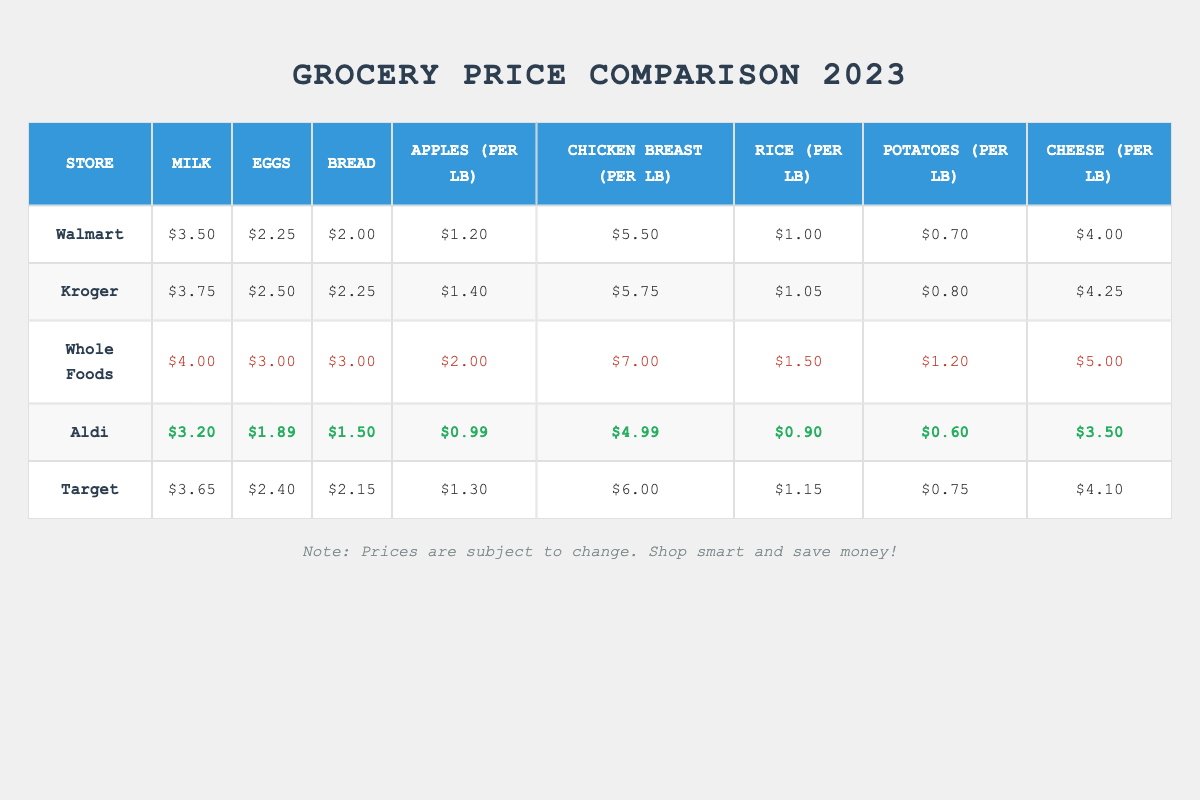What is the price of milk at Aldi? The table lists the price of milk at Aldi as $3.20, which can be found in the row corresponding to Aldi under the milk column.
Answer: $3.20 Which store offers the cheapest eggs? By comparing the prices of eggs across the stores, Aldi has the lowest price at $1.89, which can be seen in the eggs column corresponding to Aldi.
Answer: Aldi How much more expensive is chicken breast per pound at Whole Foods than at Aldi? The price of chicken breast at Whole Foods is $7.00 and at Aldi it is $4.99. The difference is $7.00 - $4.99 = $2.01, showing Whole Foods charges $2.01 more per pound.
Answer: $2.01 What is the highest price for cheese per pound and which store sells it? The highest price for cheese per pound is $5.00, found at Whole Foods in the cheese column, making it the most expensive option.
Answer: $5.00 at Whole Foods Are the prices of apples at Walmart and Kroger the same? Walmart offers apples at $1.20 per pound, while Kroger charges $1.40 per pound. Since these two values are different, they are not the same.
Answer: No What is the average price of bread across all stores? The prices for bread from each store are $2.00 (Walmart), $2.25 (Kroger), $3.00 (Whole Foods), $1.50 (Aldi), and $2.15 (Target). The total sum is $2.00 + $2.25 + $3.00 + $1.50 + $2.15 = $10.90. There are 5 stores, so the average is $10.90 / 5 = $2.18.
Answer: $2.18 Which store has the lowest total grocery price for all items combined? The total prices for each store are calculated by adding the costs of all items: Walmart ($3.50 + $2.25 + $2.00 + $1.20 + $5.50 + $1.00 + $0.70 + $4.00 = $19.15), Kroger ($3.75 + $2.50 + $2.25 + $1.40 + $5.75 + $1.05 + $0.80 + $4.25 = $21.75), Whole Foods ($4.00 + $3.00 + $3.00 + $2.00 + $7.00 + $1.50 + $1.20 + $5.00 = $26.70), Aldi ($3.20 + $1.89 + $1.50 + $0.99 + $4.99 + $0.90 + $0.60 + $3.50 = $17.57), and Target ($3.65 + $2.40 + $2.15 + $1.30 + $6.00 + $1.15 + $0.75 + $4.10 = $21.45). The lowest total is from Aldi at $17.57.
Answer: Aldi What is the difference in price for potatoes per pound between Walmart and Whole Foods? Walmart prices potatoes at $0.70 per pound while Whole Foods prices them at $1.20 per pound. The difference is $1.20 - $0.70 = $0.50.
Answer: $0.50 Is the price of rice at Kroger higher than at Aldi? At Kroger, rice costs $1.05 per pound, while Aldi offers it for $0.90. Since $1.05 is greater than $0.90, the price at Kroger is higher.
Answer: Yes Which store has the most expensive chicken breast? The price of chicken breast at each store is: Walmart ($5.50), Kroger ($5.75), Whole Foods ($7.00), Aldi ($4.99), and Target ($6.00). Whole Foods has the highest price at $7.00.
Answer: Whole Foods 